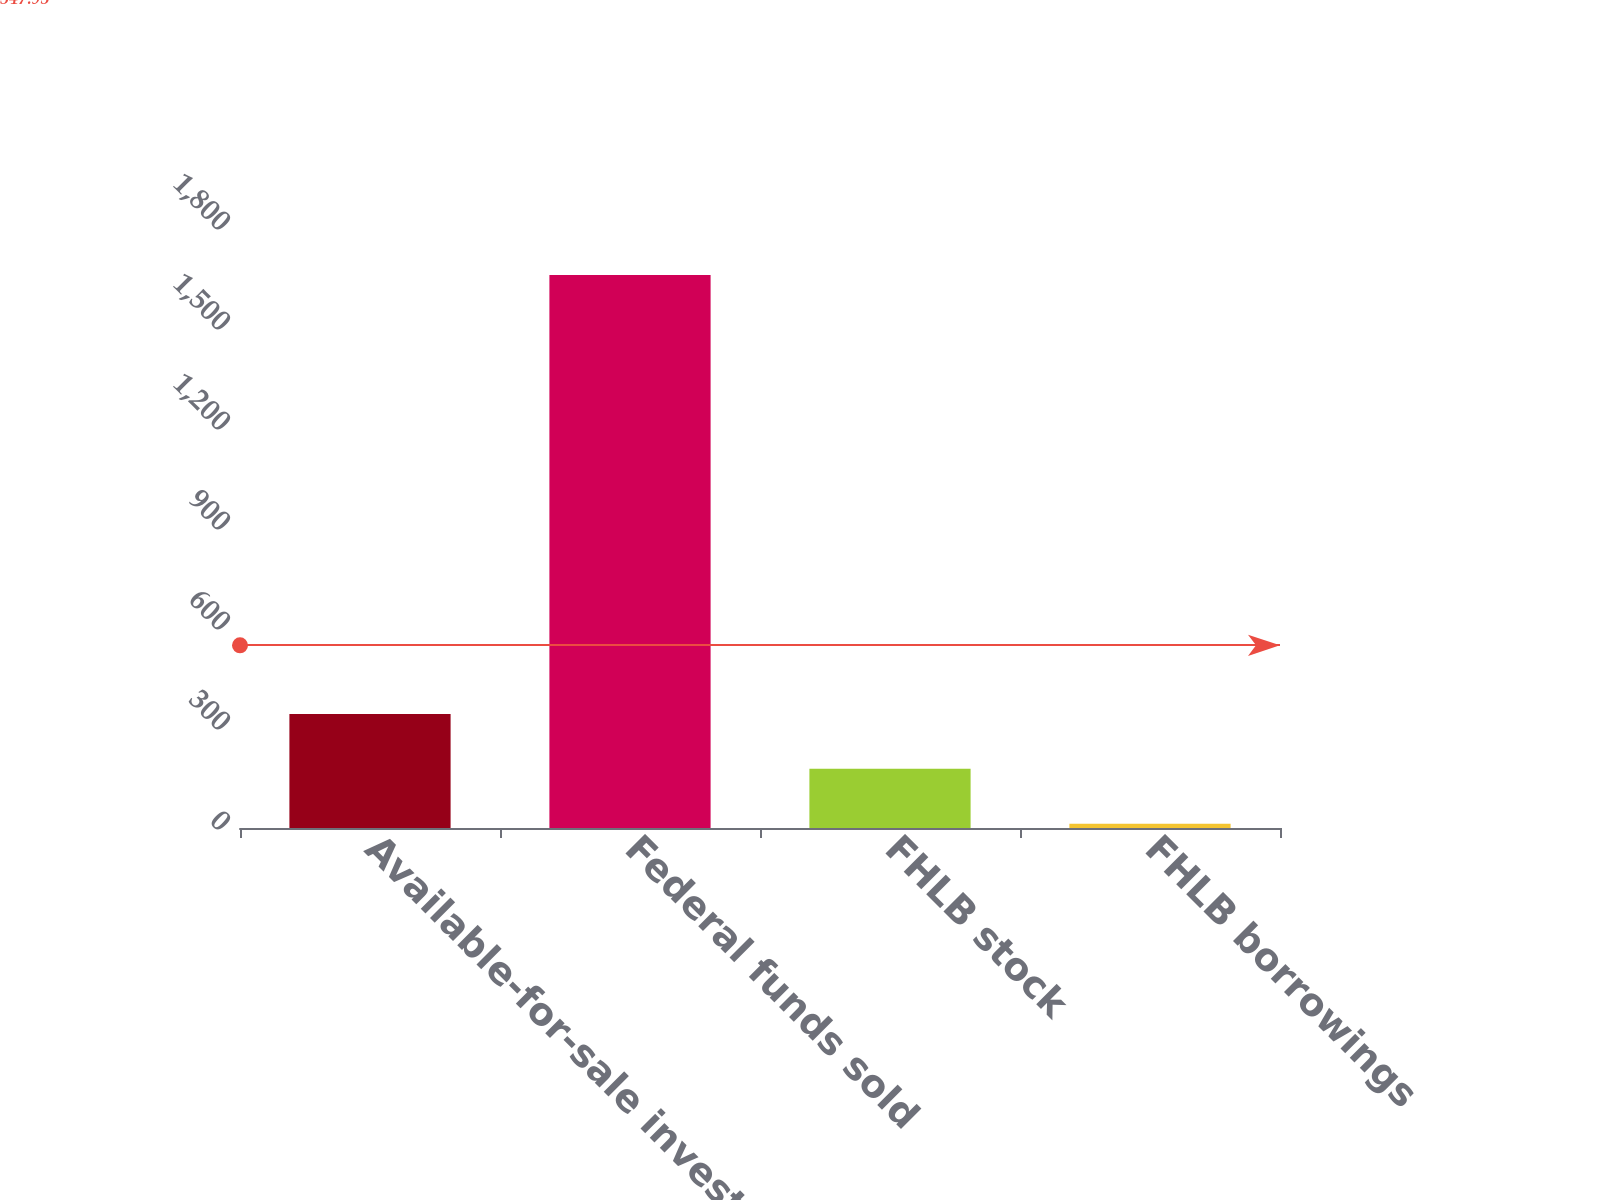Convert chart. <chart><loc_0><loc_0><loc_500><loc_500><bar_chart><fcel>Available-for-sale investment<fcel>Federal funds sold<fcel>FHLB stock<fcel>FHLB borrowings<nl><fcel>342.2<fcel>1659<fcel>177.6<fcel>13<nl></chart> 